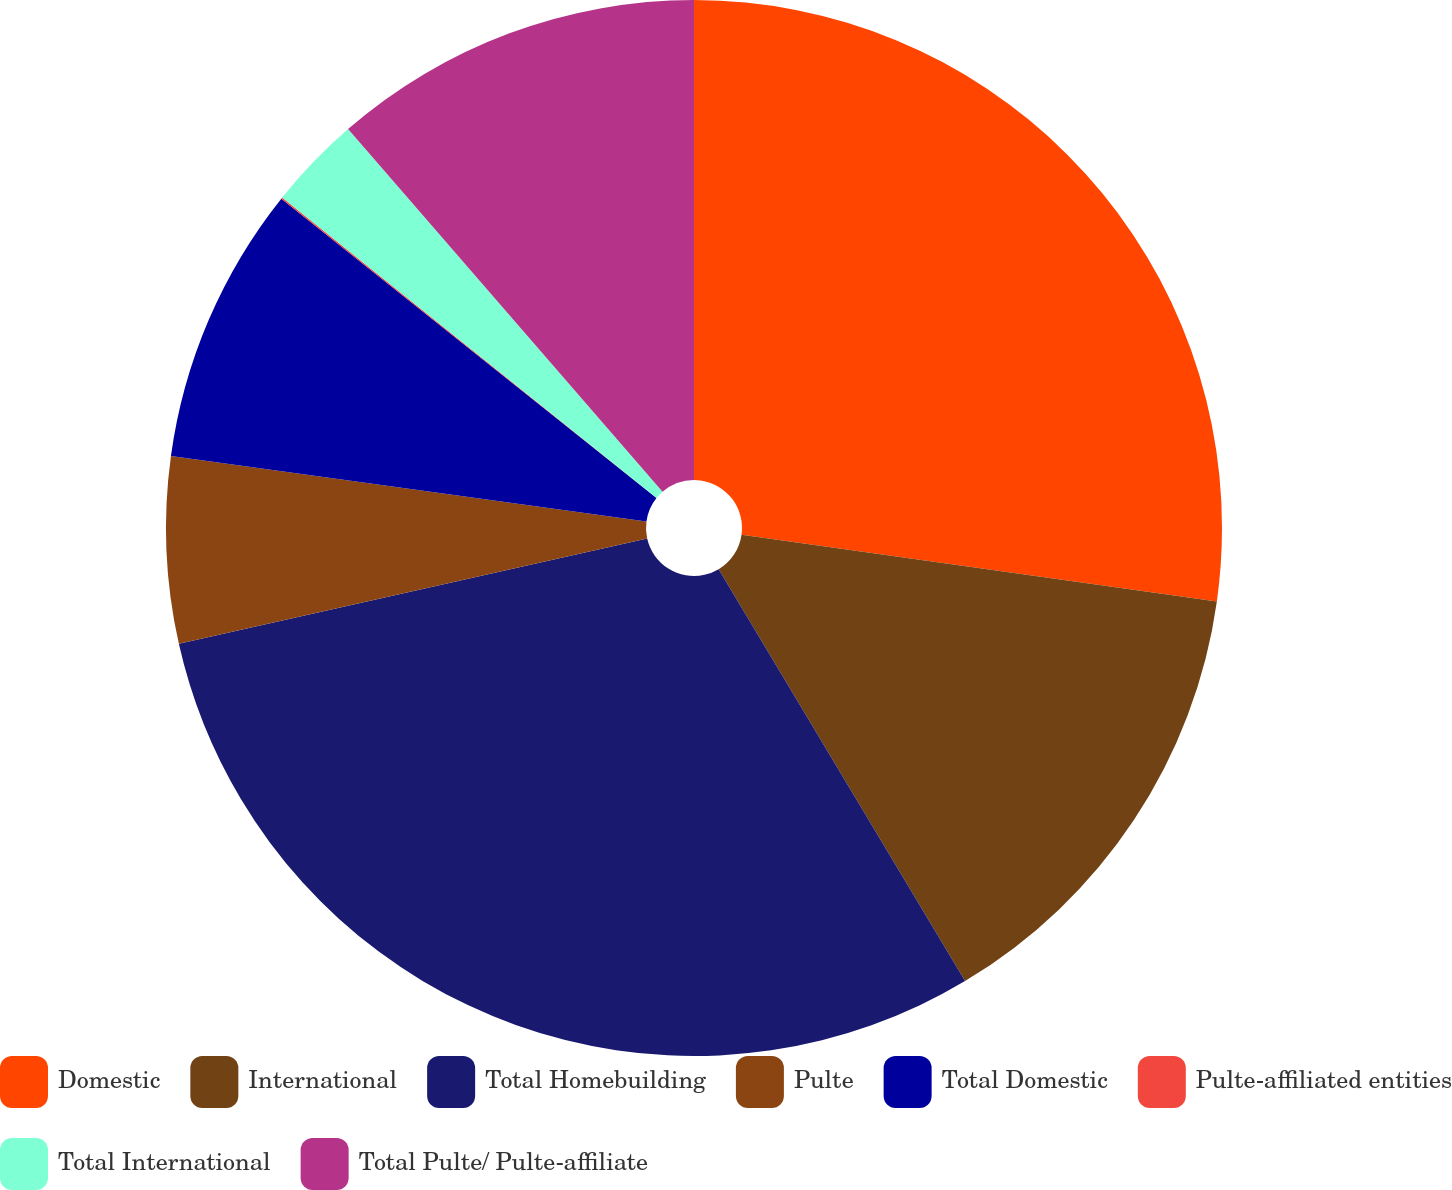<chart> <loc_0><loc_0><loc_500><loc_500><pie_chart><fcel>Domestic<fcel>International<fcel>Total Homebuilding<fcel>Pulte<fcel>Total Domestic<fcel>Pulte-affiliated entities<fcel>Total International<fcel>Total Pulte/ Pulte-affiliate<nl><fcel>27.22%<fcel>14.2%<fcel>30.06%<fcel>5.7%<fcel>8.54%<fcel>0.04%<fcel>2.87%<fcel>11.37%<nl></chart> 